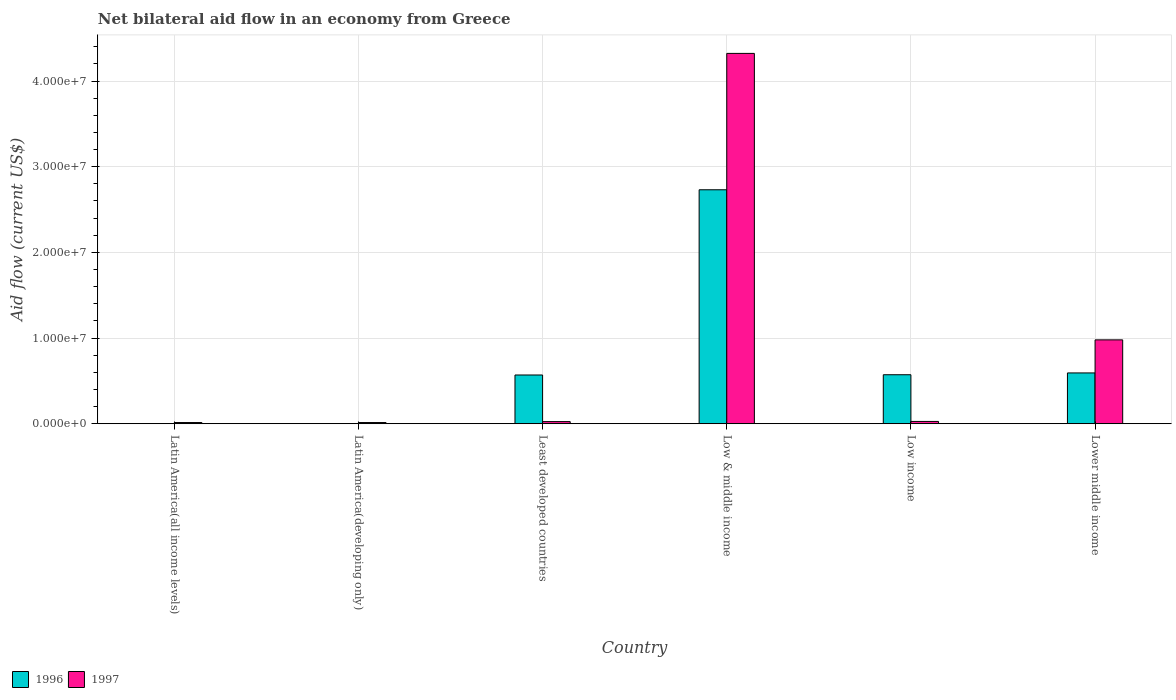How many groups of bars are there?
Your response must be concise. 6. Are the number of bars per tick equal to the number of legend labels?
Offer a terse response. Yes. Are the number of bars on each tick of the X-axis equal?
Offer a terse response. Yes. How many bars are there on the 3rd tick from the left?
Offer a terse response. 2. How many bars are there on the 4th tick from the right?
Ensure brevity in your answer.  2. What is the label of the 1st group of bars from the left?
Your response must be concise. Latin America(all income levels). What is the net bilateral aid flow in 1996 in Least developed countries?
Your response must be concise. 5.69e+06. Across all countries, what is the maximum net bilateral aid flow in 1997?
Your answer should be compact. 4.32e+07. In which country was the net bilateral aid flow in 1996 minimum?
Give a very brief answer. Latin America(all income levels). What is the total net bilateral aid flow in 1996 in the graph?
Ensure brevity in your answer.  4.47e+07. What is the difference between the net bilateral aid flow in 1997 in Least developed countries and that in Low income?
Keep it short and to the point. -2.00e+04. What is the difference between the net bilateral aid flow in 1997 in Latin America(developing only) and the net bilateral aid flow in 1996 in Low income?
Offer a terse response. -5.58e+06. What is the average net bilateral aid flow in 1997 per country?
Make the answer very short. 8.97e+06. What is the difference between the net bilateral aid flow of/in 1996 and net bilateral aid flow of/in 1997 in Least developed countries?
Make the answer very short. 5.44e+06. In how many countries, is the net bilateral aid flow in 1996 greater than 6000000 US$?
Keep it short and to the point. 1. What is the ratio of the net bilateral aid flow in 1997 in Latin America(all income levels) to that in Least developed countries?
Offer a terse response. 0.56. Is the difference between the net bilateral aid flow in 1996 in Latin America(all income levels) and Lower middle income greater than the difference between the net bilateral aid flow in 1997 in Latin America(all income levels) and Lower middle income?
Your answer should be compact. Yes. What is the difference between the highest and the second highest net bilateral aid flow in 1997?
Provide a succinct answer. 3.34e+07. What is the difference between the highest and the lowest net bilateral aid flow in 1997?
Your answer should be compact. 4.31e+07. What does the 1st bar from the right in Latin America(all income levels) represents?
Make the answer very short. 1997. How many bars are there?
Make the answer very short. 12. Are the values on the major ticks of Y-axis written in scientific E-notation?
Ensure brevity in your answer.  Yes. Does the graph contain any zero values?
Your answer should be compact. No. Does the graph contain grids?
Provide a short and direct response. Yes. Where does the legend appear in the graph?
Give a very brief answer. Bottom left. How many legend labels are there?
Provide a succinct answer. 2. What is the title of the graph?
Ensure brevity in your answer.  Net bilateral aid flow in an economy from Greece. Does "1998" appear as one of the legend labels in the graph?
Your answer should be very brief. No. What is the label or title of the Y-axis?
Your answer should be very brief. Aid flow (current US$). What is the Aid flow (current US$) of 1996 in Latin America(all income levels)?
Make the answer very short. 2.00e+04. What is the Aid flow (current US$) in 1997 in Latin America(all income levels)?
Make the answer very short. 1.40e+05. What is the Aid flow (current US$) in 1996 in Latin America(developing only)?
Keep it short and to the point. 2.00e+04. What is the Aid flow (current US$) of 1996 in Least developed countries?
Offer a very short reply. 5.69e+06. What is the Aid flow (current US$) of 1996 in Low & middle income?
Ensure brevity in your answer.  2.73e+07. What is the Aid flow (current US$) of 1997 in Low & middle income?
Give a very brief answer. 4.32e+07. What is the Aid flow (current US$) of 1996 in Low income?
Make the answer very short. 5.72e+06. What is the Aid flow (current US$) in 1997 in Low income?
Your answer should be very brief. 2.70e+05. What is the Aid flow (current US$) in 1996 in Lower middle income?
Keep it short and to the point. 5.93e+06. What is the Aid flow (current US$) in 1997 in Lower middle income?
Keep it short and to the point. 9.79e+06. Across all countries, what is the maximum Aid flow (current US$) of 1996?
Offer a very short reply. 2.73e+07. Across all countries, what is the maximum Aid flow (current US$) in 1997?
Your response must be concise. 4.32e+07. Across all countries, what is the minimum Aid flow (current US$) in 1996?
Provide a succinct answer. 2.00e+04. Across all countries, what is the minimum Aid flow (current US$) of 1997?
Ensure brevity in your answer.  1.40e+05. What is the total Aid flow (current US$) of 1996 in the graph?
Give a very brief answer. 4.47e+07. What is the total Aid flow (current US$) of 1997 in the graph?
Keep it short and to the point. 5.38e+07. What is the difference between the Aid flow (current US$) in 1996 in Latin America(all income levels) and that in Latin America(developing only)?
Offer a very short reply. 0. What is the difference between the Aid flow (current US$) of 1997 in Latin America(all income levels) and that in Latin America(developing only)?
Your answer should be very brief. 0. What is the difference between the Aid flow (current US$) of 1996 in Latin America(all income levels) and that in Least developed countries?
Make the answer very short. -5.67e+06. What is the difference between the Aid flow (current US$) of 1997 in Latin America(all income levels) and that in Least developed countries?
Offer a very short reply. -1.10e+05. What is the difference between the Aid flow (current US$) of 1996 in Latin America(all income levels) and that in Low & middle income?
Offer a terse response. -2.73e+07. What is the difference between the Aid flow (current US$) of 1997 in Latin America(all income levels) and that in Low & middle income?
Ensure brevity in your answer.  -4.31e+07. What is the difference between the Aid flow (current US$) in 1996 in Latin America(all income levels) and that in Low income?
Your answer should be compact. -5.70e+06. What is the difference between the Aid flow (current US$) of 1997 in Latin America(all income levels) and that in Low income?
Provide a succinct answer. -1.30e+05. What is the difference between the Aid flow (current US$) in 1996 in Latin America(all income levels) and that in Lower middle income?
Your answer should be compact. -5.91e+06. What is the difference between the Aid flow (current US$) of 1997 in Latin America(all income levels) and that in Lower middle income?
Your answer should be compact. -9.65e+06. What is the difference between the Aid flow (current US$) of 1996 in Latin America(developing only) and that in Least developed countries?
Provide a succinct answer. -5.67e+06. What is the difference between the Aid flow (current US$) of 1997 in Latin America(developing only) and that in Least developed countries?
Your response must be concise. -1.10e+05. What is the difference between the Aid flow (current US$) in 1996 in Latin America(developing only) and that in Low & middle income?
Keep it short and to the point. -2.73e+07. What is the difference between the Aid flow (current US$) in 1997 in Latin America(developing only) and that in Low & middle income?
Ensure brevity in your answer.  -4.31e+07. What is the difference between the Aid flow (current US$) of 1996 in Latin America(developing only) and that in Low income?
Keep it short and to the point. -5.70e+06. What is the difference between the Aid flow (current US$) of 1997 in Latin America(developing only) and that in Low income?
Keep it short and to the point. -1.30e+05. What is the difference between the Aid flow (current US$) of 1996 in Latin America(developing only) and that in Lower middle income?
Your answer should be very brief. -5.91e+06. What is the difference between the Aid flow (current US$) of 1997 in Latin America(developing only) and that in Lower middle income?
Keep it short and to the point. -9.65e+06. What is the difference between the Aid flow (current US$) of 1996 in Least developed countries and that in Low & middle income?
Offer a very short reply. -2.16e+07. What is the difference between the Aid flow (current US$) in 1997 in Least developed countries and that in Low & middle income?
Ensure brevity in your answer.  -4.30e+07. What is the difference between the Aid flow (current US$) in 1996 in Least developed countries and that in Low income?
Ensure brevity in your answer.  -3.00e+04. What is the difference between the Aid flow (current US$) of 1997 in Least developed countries and that in Low income?
Provide a short and direct response. -2.00e+04. What is the difference between the Aid flow (current US$) of 1997 in Least developed countries and that in Lower middle income?
Give a very brief answer. -9.54e+06. What is the difference between the Aid flow (current US$) in 1996 in Low & middle income and that in Low income?
Offer a very short reply. 2.16e+07. What is the difference between the Aid flow (current US$) of 1997 in Low & middle income and that in Low income?
Keep it short and to the point. 4.30e+07. What is the difference between the Aid flow (current US$) in 1996 in Low & middle income and that in Lower middle income?
Offer a terse response. 2.14e+07. What is the difference between the Aid flow (current US$) of 1997 in Low & middle income and that in Lower middle income?
Keep it short and to the point. 3.34e+07. What is the difference between the Aid flow (current US$) in 1996 in Low income and that in Lower middle income?
Ensure brevity in your answer.  -2.10e+05. What is the difference between the Aid flow (current US$) in 1997 in Low income and that in Lower middle income?
Make the answer very short. -9.52e+06. What is the difference between the Aid flow (current US$) in 1996 in Latin America(all income levels) and the Aid flow (current US$) in 1997 in Latin America(developing only)?
Offer a very short reply. -1.20e+05. What is the difference between the Aid flow (current US$) in 1996 in Latin America(all income levels) and the Aid flow (current US$) in 1997 in Least developed countries?
Offer a very short reply. -2.30e+05. What is the difference between the Aid flow (current US$) of 1996 in Latin America(all income levels) and the Aid flow (current US$) of 1997 in Low & middle income?
Give a very brief answer. -4.32e+07. What is the difference between the Aid flow (current US$) in 1996 in Latin America(all income levels) and the Aid flow (current US$) in 1997 in Low income?
Provide a succinct answer. -2.50e+05. What is the difference between the Aid flow (current US$) of 1996 in Latin America(all income levels) and the Aid flow (current US$) of 1997 in Lower middle income?
Keep it short and to the point. -9.77e+06. What is the difference between the Aid flow (current US$) of 1996 in Latin America(developing only) and the Aid flow (current US$) of 1997 in Least developed countries?
Offer a very short reply. -2.30e+05. What is the difference between the Aid flow (current US$) in 1996 in Latin America(developing only) and the Aid flow (current US$) in 1997 in Low & middle income?
Give a very brief answer. -4.32e+07. What is the difference between the Aid flow (current US$) in 1996 in Latin America(developing only) and the Aid flow (current US$) in 1997 in Low income?
Offer a terse response. -2.50e+05. What is the difference between the Aid flow (current US$) in 1996 in Latin America(developing only) and the Aid flow (current US$) in 1997 in Lower middle income?
Your response must be concise. -9.77e+06. What is the difference between the Aid flow (current US$) of 1996 in Least developed countries and the Aid flow (current US$) of 1997 in Low & middle income?
Provide a short and direct response. -3.75e+07. What is the difference between the Aid flow (current US$) of 1996 in Least developed countries and the Aid flow (current US$) of 1997 in Low income?
Make the answer very short. 5.42e+06. What is the difference between the Aid flow (current US$) of 1996 in Least developed countries and the Aid flow (current US$) of 1997 in Lower middle income?
Keep it short and to the point. -4.10e+06. What is the difference between the Aid flow (current US$) in 1996 in Low & middle income and the Aid flow (current US$) in 1997 in Low income?
Keep it short and to the point. 2.70e+07. What is the difference between the Aid flow (current US$) in 1996 in Low & middle income and the Aid flow (current US$) in 1997 in Lower middle income?
Offer a very short reply. 1.75e+07. What is the difference between the Aid flow (current US$) of 1996 in Low income and the Aid flow (current US$) of 1997 in Lower middle income?
Offer a very short reply. -4.07e+06. What is the average Aid flow (current US$) of 1996 per country?
Your response must be concise. 7.45e+06. What is the average Aid flow (current US$) in 1997 per country?
Provide a succinct answer. 8.97e+06. What is the difference between the Aid flow (current US$) in 1996 and Aid flow (current US$) in 1997 in Least developed countries?
Make the answer very short. 5.44e+06. What is the difference between the Aid flow (current US$) of 1996 and Aid flow (current US$) of 1997 in Low & middle income?
Your response must be concise. -1.59e+07. What is the difference between the Aid flow (current US$) in 1996 and Aid flow (current US$) in 1997 in Low income?
Your response must be concise. 5.45e+06. What is the difference between the Aid flow (current US$) of 1996 and Aid flow (current US$) of 1997 in Lower middle income?
Give a very brief answer. -3.86e+06. What is the ratio of the Aid flow (current US$) in 1996 in Latin America(all income levels) to that in Least developed countries?
Offer a very short reply. 0. What is the ratio of the Aid flow (current US$) in 1997 in Latin America(all income levels) to that in Least developed countries?
Ensure brevity in your answer.  0.56. What is the ratio of the Aid flow (current US$) of 1996 in Latin America(all income levels) to that in Low & middle income?
Provide a succinct answer. 0. What is the ratio of the Aid flow (current US$) of 1997 in Latin America(all income levels) to that in Low & middle income?
Make the answer very short. 0. What is the ratio of the Aid flow (current US$) in 1996 in Latin America(all income levels) to that in Low income?
Your response must be concise. 0. What is the ratio of the Aid flow (current US$) in 1997 in Latin America(all income levels) to that in Low income?
Offer a very short reply. 0.52. What is the ratio of the Aid flow (current US$) of 1996 in Latin America(all income levels) to that in Lower middle income?
Make the answer very short. 0. What is the ratio of the Aid flow (current US$) in 1997 in Latin America(all income levels) to that in Lower middle income?
Your answer should be compact. 0.01. What is the ratio of the Aid flow (current US$) in 1996 in Latin America(developing only) to that in Least developed countries?
Your response must be concise. 0. What is the ratio of the Aid flow (current US$) in 1997 in Latin America(developing only) to that in Least developed countries?
Make the answer very short. 0.56. What is the ratio of the Aid flow (current US$) in 1996 in Latin America(developing only) to that in Low & middle income?
Provide a succinct answer. 0. What is the ratio of the Aid flow (current US$) in 1997 in Latin America(developing only) to that in Low & middle income?
Your answer should be very brief. 0. What is the ratio of the Aid flow (current US$) in 1996 in Latin America(developing only) to that in Low income?
Make the answer very short. 0. What is the ratio of the Aid flow (current US$) of 1997 in Latin America(developing only) to that in Low income?
Ensure brevity in your answer.  0.52. What is the ratio of the Aid flow (current US$) in 1996 in Latin America(developing only) to that in Lower middle income?
Offer a terse response. 0. What is the ratio of the Aid flow (current US$) of 1997 in Latin America(developing only) to that in Lower middle income?
Offer a very short reply. 0.01. What is the ratio of the Aid flow (current US$) in 1996 in Least developed countries to that in Low & middle income?
Provide a short and direct response. 0.21. What is the ratio of the Aid flow (current US$) in 1997 in Least developed countries to that in Low & middle income?
Offer a very short reply. 0.01. What is the ratio of the Aid flow (current US$) in 1996 in Least developed countries to that in Low income?
Your answer should be compact. 0.99. What is the ratio of the Aid flow (current US$) of 1997 in Least developed countries to that in Low income?
Provide a succinct answer. 0.93. What is the ratio of the Aid flow (current US$) in 1996 in Least developed countries to that in Lower middle income?
Provide a short and direct response. 0.96. What is the ratio of the Aid flow (current US$) in 1997 in Least developed countries to that in Lower middle income?
Offer a terse response. 0.03. What is the ratio of the Aid flow (current US$) in 1996 in Low & middle income to that in Low income?
Ensure brevity in your answer.  4.77. What is the ratio of the Aid flow (current US$) in 1997 in Low & middle income to that in Low income?
Make the answer very short. 160.11. What is the ratio of the Aid flow (current US$) of 1996 in Low & middle income to that in Lower middle income?
Give a very brief answer. 4.61. What is the ratio of the Aid flow (current US$) in 1997 in Low & middle income to that in Lower middle income?
Provide a succinct answer. 4.42. What is the ratio of the Aid flow (current US$) of 1996 in Low income to that in Lower middle income?
Your response must be concise. 0.96. What is the ratio of the Aid flow (current US$) in 1997 in Low income to that in Lower middle income?
Provide a short and direct response. 0.03. What is the difference between the highest and the second highest Aid flow (current US$) in 1996?
Provide a short and direct response. 2.14e+07. What is the difference between the highest and the second highest Aid flow (current US$) of 1997?
Your answer should be very brief. 3.34e+07. What is the difference between the highest and the lowest Aid flow (current US$) in 1996?
Ensure brevity in your answer.  2.73e+07. What is the difference between the highest and the lowest Aid flow (current US$) in 1997?
Provide a succinct answer. 4.31e+07. 